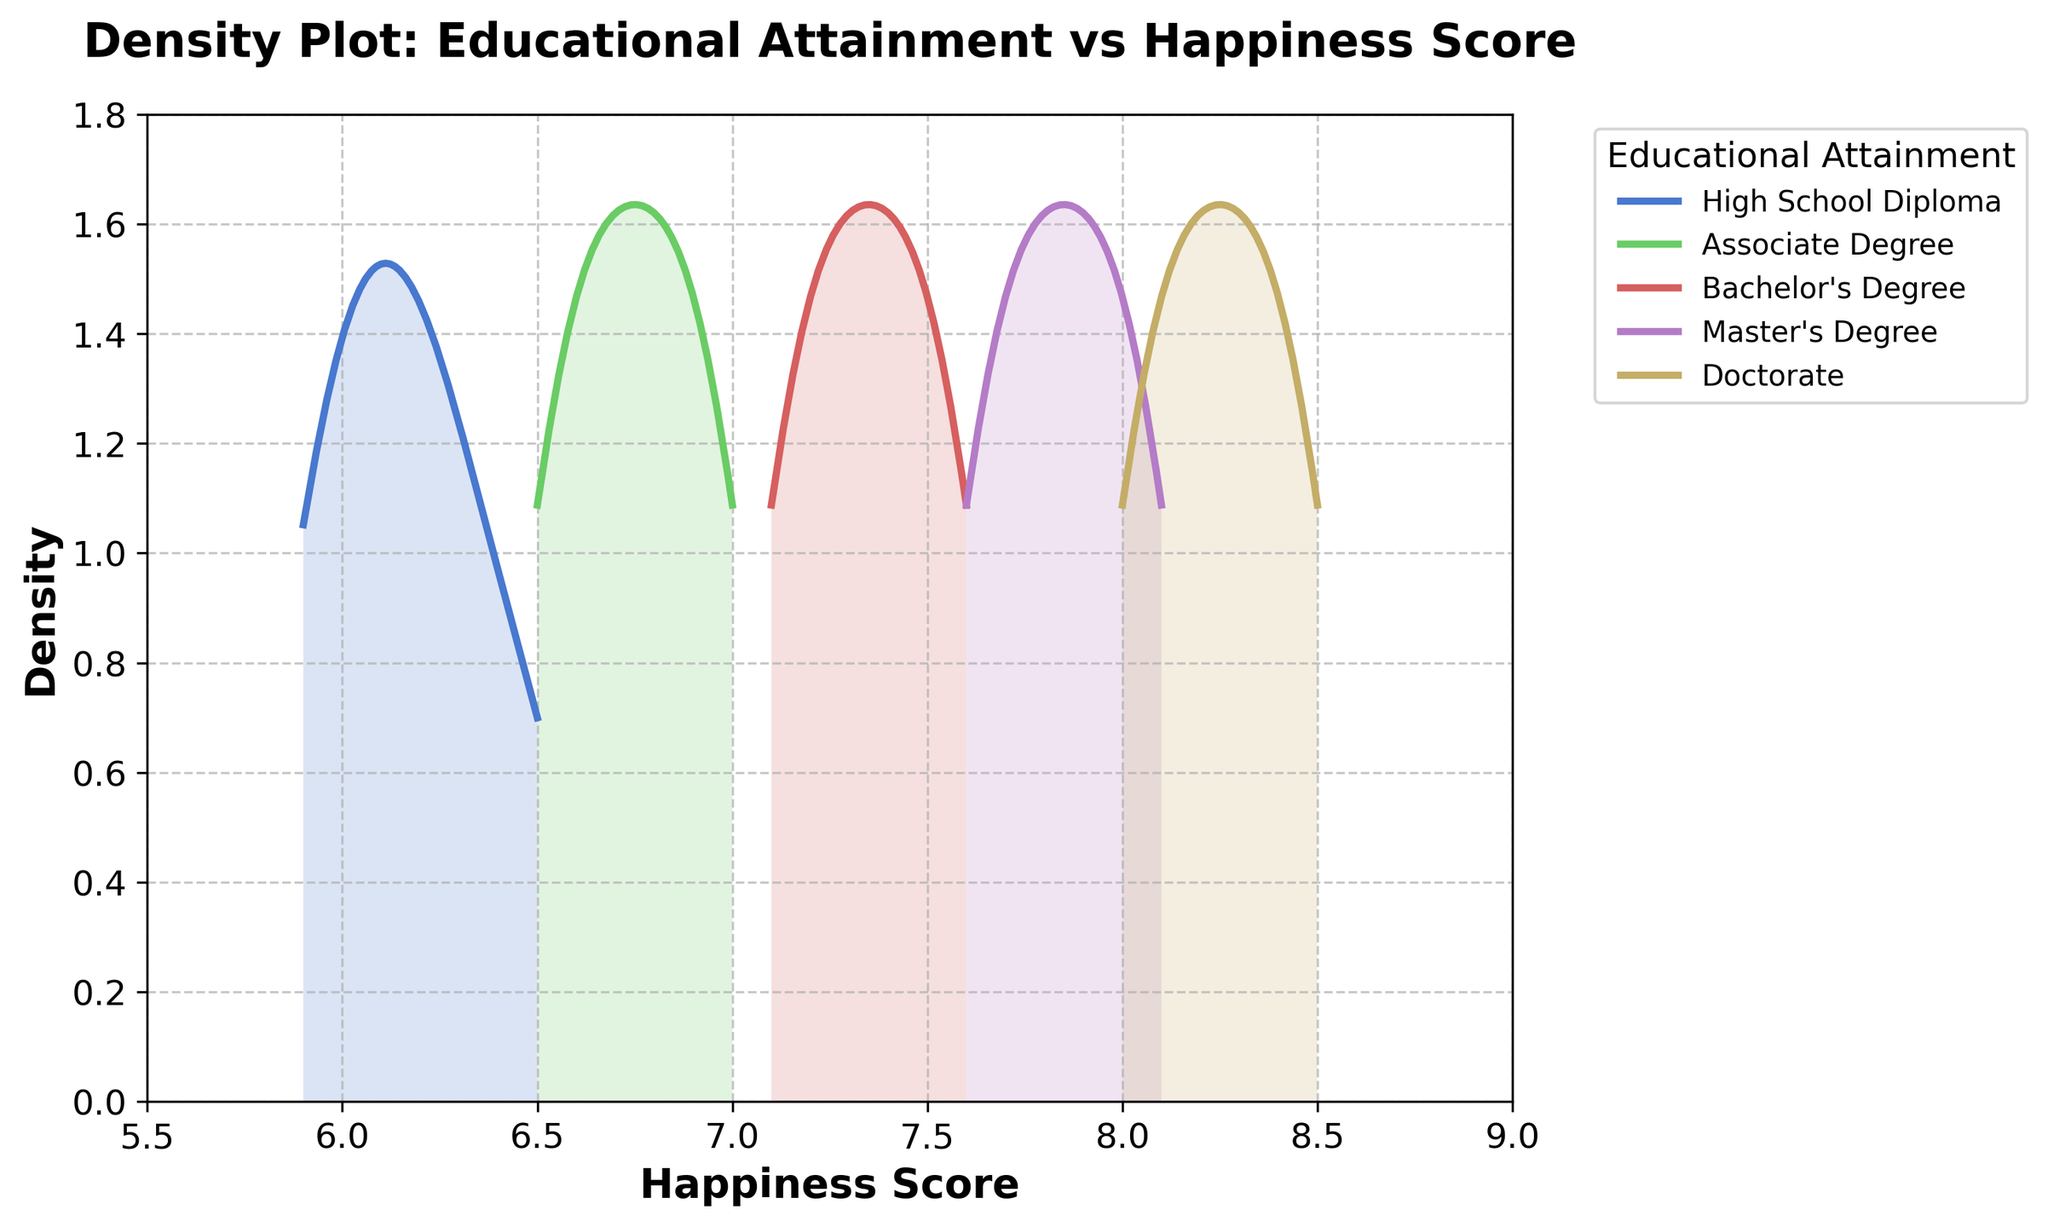What is the title of the figure? The title of the figure is displayed at the top and reads "Density Plot: Educational Attainment vs Happiness Score."
Answer: Density Plot: Educational Attainment vs Happiness Score Which axis represents the Happiness Score? The plot shows "Happiness Score" on the x-axis, which is the horizontal axis.
Answer: x-axis Which educational attainment category has the highest peak in its density curve? The "Doctorate" category has the highest peak in its density curve as observed from the plot.
Answer: Doctorate What are the components of the density plot that show the range of happiness scores for each educational attainment level? The density curves for each educational attainment level indicate the range of happiness scores. The shaded area under each curve shows the density distribution for that range.
Answer: Density curves Between "Bachelor's Degree" and "Master's Degree," which one has a higher average Happiness Score based on the density plot? The peak of the density curve for the "Master's Degree" is located at a higher happiness score compared to the peak of the "Bachelor's Degree" curve, indicating a higher average Happiness Score.
Answer: Master's Degree Are the density curves for "High School Diploma" and "Associate Degree" overlapping? Yes, the density curves for "High School Diploma" and "Associate Degree" have areas of overlap, indicating some common happiness scores between the two education levels.
Answer: Yes What is the approximate range of happiness scores for individuals with a Doctorate based on the plot? The density curve for the "Doctorate" ranges approximately from a happiness score of 8.0 to 8.5.
Answer: 8.0 to 8.5 Which educational attainment category has the widest spread in happiness scores? The "High School Diploma" category has the widest spread, as its density curve spans a larger range of happiness scores compared to the other categories.
Answer: High School Diploma How does the density curve for "Associate Degree" compare to "Master's Degree" in terms of spread and peak? The density curve for "Associate Degree" has a narrower spread and a lower peak compared to the "Master's Degree," which suggests that the range of happiness scores is narrower and the average happiness score is slightly lower for "Associate Degree."
Answer: Narrower spread and lower peak Does obtaining a higher educational level correlate with an increase in average happiness scores based on the plot? Yes, as the educational attainment level increases from "High School Diploma" to "Doctorate," the peaks of the density curves shift towards higher happiness scores, indicating a positive correlation.
Answer: Yes 